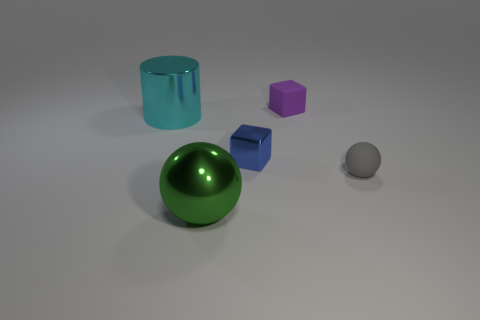What color is the large metal ball?
Your answer should be very brief. Green. There is a big object on the left side of the green thing; is it the same color as the tiny ball?
Keep it short and to the point. No. There is a purple thing that is the same size as the blue block; what shape is it?
Give a very brief answer. Cube. What is the shape of the green metal object?
Offer a very short reply. Sphere. Is the material of the big thing to the left of the large green metal thing the same as the blue cube?
Ensure brevity in your answer.  Yes. There is a sphere on the left side of the tiny block that is behind the tiny blue shiny object; what is its size?
Ensure brevity in your answer.  Large. There is a thing that is both right of the cylinder and behind the tiny blue metallic cube; what color is it?
Provide a succinct answer. Purple. What material is the object that is the same size as the cyan cylinder?
Make the answer very short. Metal. What number of other things are there of the same material as the blue block
Give a very brief answer. 2. There is a shiny thing to the right of the big green metallic object; is its color the same as the ball that is behind the large sphere?
Offer a terse response. No. 